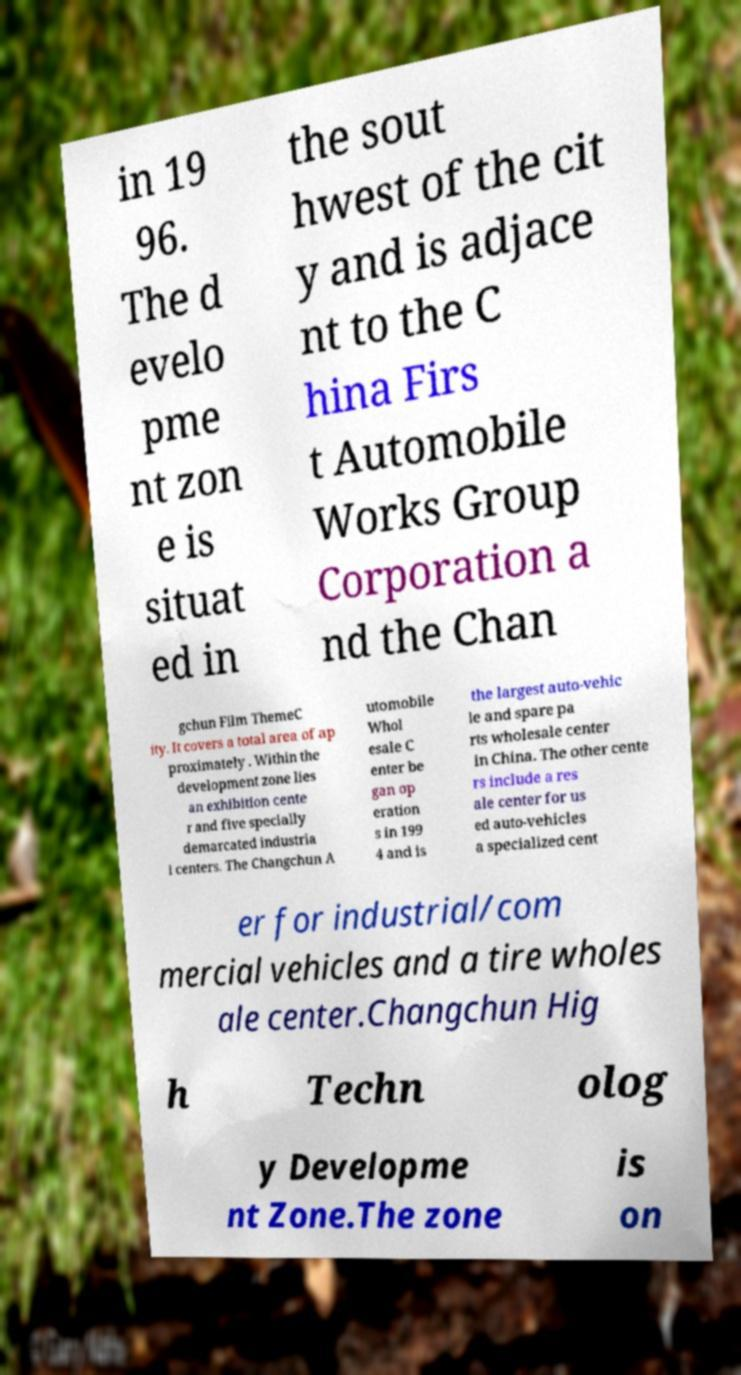Can you read and provide the text displayed in the image?This photo seems to have some interesting text. Can you extract and type it out for me? in 19 96. The d evelo pme nt zon e is situat ed in the sout hwest of the cit y and is adjace nt to the C hina Firs t Automobile Works Group Corporation a nd the Chan gchun Film ThemeC ity. It covers a total area of ap proximately . Within the development zone lies an exhibition cente r and five specially demarcated industria l centers. The Changchun A utomobile Whol esale C enter be gan op eration s in 199 4 and is the largest auto-vehic le and spare pa rts wholesale center in China. The other cente rs include a res ale center for us ed auto-vehicles a specialized cent er for industrial/com mercial vehicles and a tire wholes ale center.Changchun Hig h Techn olog y Developme nt Zone.The zone is on 